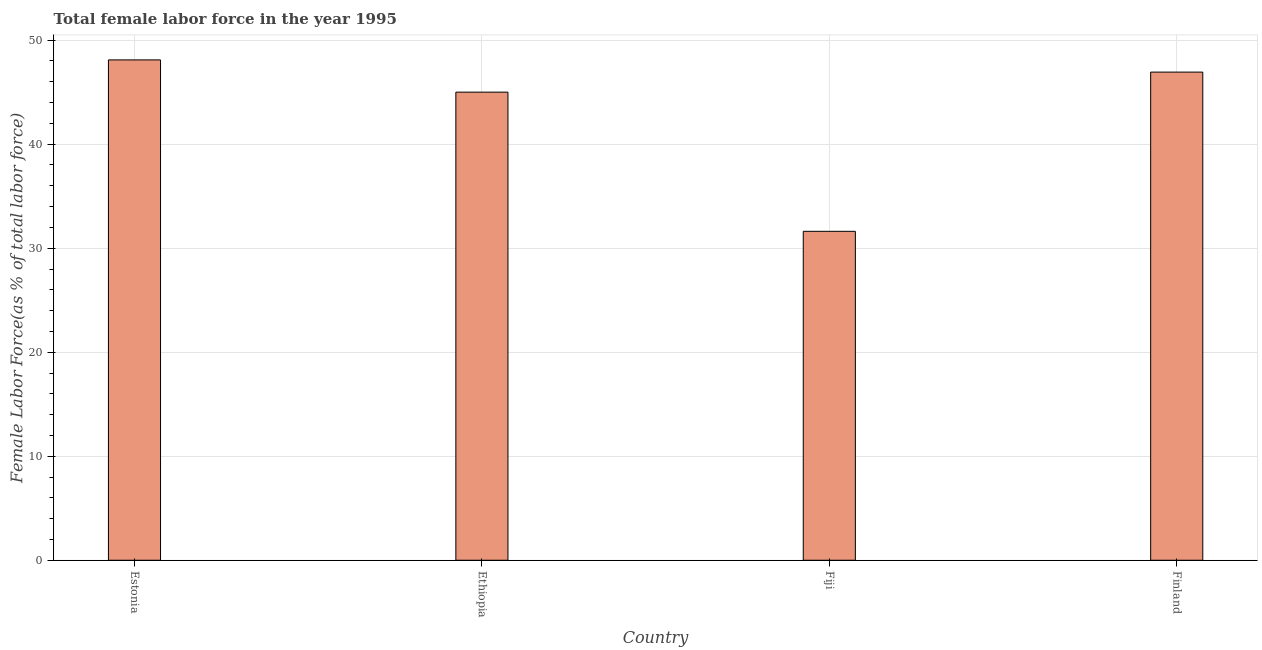Does the graph contain any zero values?
Provide a short and direct response. No. Does the graph contain grids?
Ensure brevity in your answer.  Yes. What is the title of the graph?
Give a very brief answer. Total female labor force in the year 1995. What is the label or title of the X-axis?
Your answer should be very brief. Country. What is the label or title of the Y-axis?
Your answer should be compact. Female Labor Force(as % of total labor force). What is the total female labor force in Estonia?
Make the answer very short. 48.1. Across all countries, what is the maximum total female labor force?
Your response must be concise. 48.1. Across all countries, what is the minimum total female labor force?
Ensure brevity in your answer.  31.62. In which country was the total female labor force maximum?
Ensure brevity in your answer.  Estonia. In which country was the total female labor force minimum?
Ensure brevity in your answer.  Fiji. What is the sum of the total female labor force?
Your answer should be very brief. 171.66. What is the difference between the total female labor force in Estonia and Ethiopia?
Ensure brevity in your answer.  3.1. What is the average total female labor force per country?
Provide a short and direct response. 42.91. What is the median total female labor force?
Your answer should be compact. 45.97. What is the ratio of the total female labor force in Estonia to that in Ethiopia?
Your response must be concise. 1.07. Is the total female labor force in Estonia less than that in Fiji?
Your answer should be compact. No. Is the difference between the total female labor force in Ethiopia and Finland greater than the difference between any two countries?
Give a very brief answer. No. What is the difference between the highest and the second highest total female labor force?
Make the answer very short. 1.17. Is the sum of the total female labor force in Estonia and Ethiopia greater than the maximum total female labor force across all countries?
Provide a short and direct response. Yes. What is the difference between the highest and the lowest total female labor force?
Give a very brief answer. 16.48. How many bars are there?
Provide a short and direct response. 4. What is the difference between two consecutive major ticks on the Y-axis?
Your answer should be very brief. 10. Are the values on the major ticks of Y-axis written in scientific E-notation?
Give a very brief answer. No. What is the Female Labor Force(as % of total labor force) of Estonia?
Your response must be concise. 48.1. What is the Female Labor Force(as % of total labor force) in Ethiopia?
Your answer should be very brief. 45. What is the Female Labor Force(as % of total labor force) of Fiji?
Ensure brevity in your answer.  31.62. What is the Female Labor Force(as % of total labor force) of Finland?
Ensure brevity in your answer.  46.93. What is the difference between the Female Labor Force(as % of total labor force) in Estonia and Ethiopia?
Give a very brief answer. 3.1. What is the difference between the Female Labor Force(as % of total labor force) in Estonia and Fiji?
Offer a terse response. 16.48. What is the difference between the Female Labor Force(as % of total labor force) in Estonia and Finland?
Give a very brief answer. 1.17. What is the difference between the Female Labor Force(as % of total labor force) in Ethiopia and Fiji?
Provide a succinct answer. 13.38. What is the difference between the Female Labor Force(as % of total labor force) in Ethiopia and Finland?
Keep it short and to the point. -1.93. What is the difference between the Female Labor Force(as % of total labor force) in Fiji and Finland?
Give a very brief answer. -15.31. What is the ratio of the Female Labor Force(as % of total labor force) in Estonia to that in Ethiopia?
Offer a very short reply. 1.07. What is the ratio of the Female Labor Force(as % of total labor force) in Estonia to that in Fiji?
Make the answer very short. 1.52. What is the ratio of the Female Labor Force(as % of total labor force) in Estonia to that in Finland?
Ensure brevity in your answer.  1.02. What is the ratio of the Female Labor Force(as % of total labor force) in Ethiopia to that in Fiji?
Keep it short and to the point. 1.42. What is the ratio of the Female Labor Force(as % of total labor force) in Fiji to that in Finland?
Offer a very short reply. 0.67. 